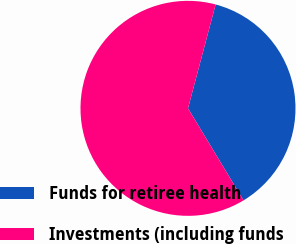Convert chart. <chart><loc_0><loc_0><loc_500><loc_500><pie_chart><fcel>Funds for retiree health<fcel>Investments (including funds<nl><fcel>37.22%<fcel>62.78%<nl></chart> 